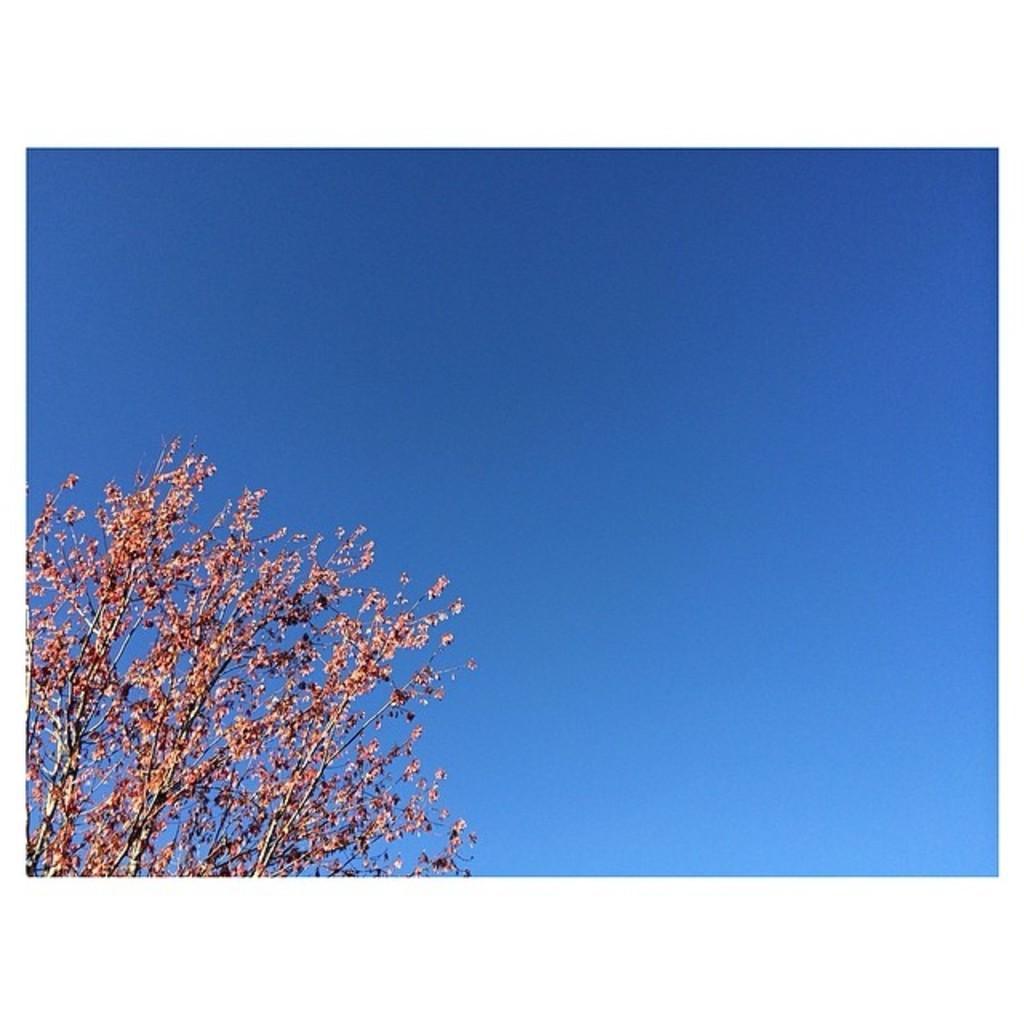How would you summarize this image in a sentence or two? In this image we can see some branches of a tree. We can also see the sky which looks cloudy. 